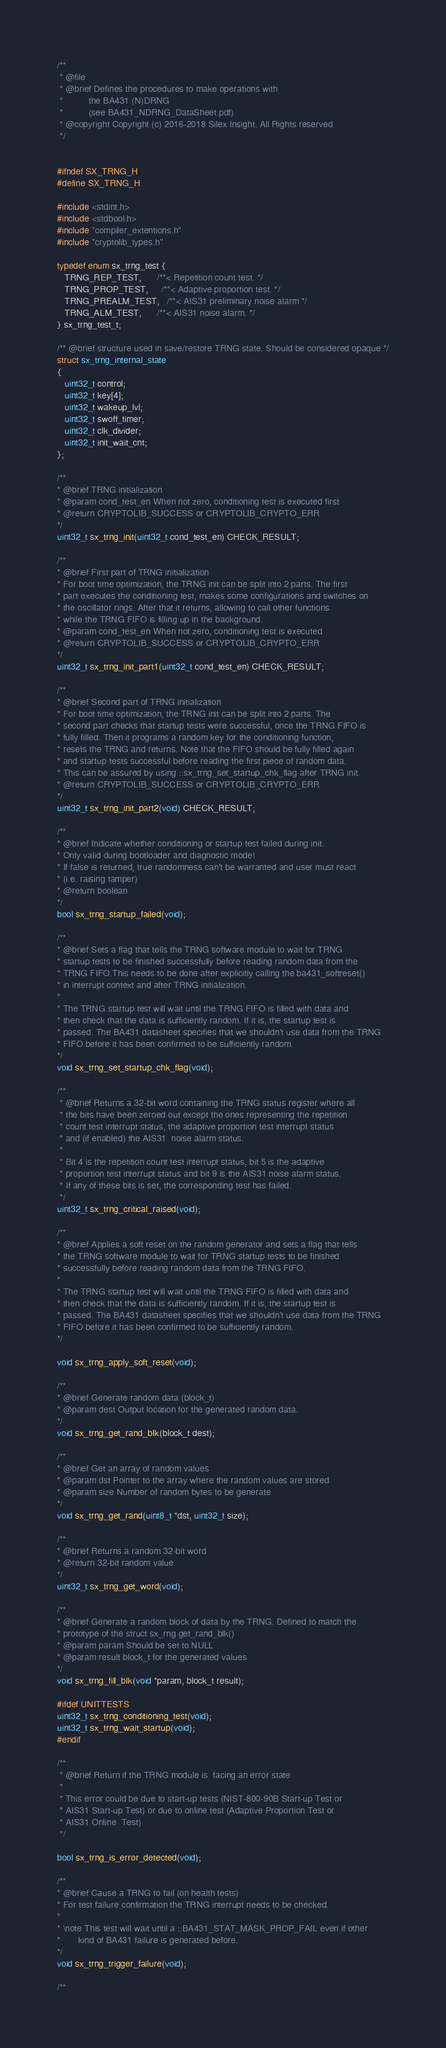Convert code to text. <code><loc_0><loc_0><loc_500><loc_500><_C_>/**
 * @file
 * @brief Defines the procedures to make operations with
 *          the BA431 (N)DRNG
 *          (see BA431_NDRNG_DataSheet.pdf)
 * @copyright Copyright (c) 2016-2018 Silex Insight. All Rights reserved
 */


#ifndef SX_TRNG_H
#define SX_TRNG_H

#include <stdint.h>
#include <stdbool.h>
#include "compiler_extentions.h"
#include "cryptolib_types.h"

typedef enum sx_trng_test {
   TRNG_REP_TEST,      /**< Repetition count test. */
   TRNG_PROP_TEST,     /**< Adaptive proportion test. */
   TRNG_PREALM_TEST,   /**< AIS31 preliminary noise alarm */
   TRNG_ALM_TEST,      /**< AIS31 noise alarm. */
} sx_trng_test_t;

/** @brief structure used in save/restore TRNG state. Should be considered opaque */
struct sx_trng_internal_state
{
   uint32_t control;
   uint32_t key[4];
   uint32_t wakeup_lvl;
   uint32_t swoff_timer;
   uint32_t clk_divider;
   uint32_t init_wait_cnt;
};

/**
* @brief TRNG initialization
* @param cond_test_en When not zero, conditioning test is executed first
* @return CRYPTOLIB_SUCCESS or CRYPTOLIB_CRYPTO_ERR
*/
uint32_t sx_trng_init(uint32_t cond_test_en) CHECK_RESULT;

/**
* @brief First part of TRNG initialization
* For boot time optimization, the TRNG init can be split into 2 parts. The first
* part executes the conditioning test, makes some configurations and switches on
* the oscillator rings. After that it returns, allowing to call other functions
* while the TRNG FIFO is filling up in the background.
* @param cond_test_en When not zero, conditioning test is executed
* @return CRYPTOLIB_SUCCESS or CRYPTOLIB_CRYPTO_ERR
*/
uint32_t sx_trng_init_part1(uint32_t cond_test_en) CHECK_RESULT;

/**
* @brief Second part of TRNG initialization
* For boot time optimization, the TRNG init can be split into 2 parts. The
* second part checks that startup tests were successful, once the TRNG FIFO is
* fully filled. Then it programs a random key for the conditioning function,
* resets the TRNG and returns. Note that the FIFO should be fully filled again
* and startup tests successful before reading the first piece of random data.
* This can be assured by using ::sx_trng_set_startup_chk_flag after TRNG init.
* @return CRYPTOLIB_SUCCESS or CRYPTOLIB_CRYPTO_ERR
*/
uint32_t sx_trng_init_part2(void) CHECK_RESULT;

/**
* @brief Indicate whether conditioning or startup test failed during init.
* Only valid during bootloader and diagnostic mode!
* If false is returned, true randomness can't be warranted and user must react
* (i.e. raising tamper)
* @return boolean
*/
bool sx_trng_startup_failed(void);

/**
* @brief Sets a flag that tells the TRNG software module to wait for TRNG
* startup tests to be finished successfully before reading random data from the
* TRNG FIFO.This needs to be done after explicitly calling the ba431_softreset()
* in interrupt context and after TRNG initialization.
*
* The TRNG startup test will wait until the TRNG FIFO is filled with data and
* then check that the data is sufficiently random. If it is, the startup test is
* passed. The BA431 datasheet specifies that we shouldn't use data from the TRNG
* FIFO before it has been confirmed to be sufficiently random.
*/
void sx_trng_set_startup_chk_flag(void);

/**
 * @brief Returns a 32-bit word containing the TRNG status register where all
 * the bits have been zeroed out except the ones representing the repetition
 * count test interrupt status, the adaptive proportion test interrupt status
 * and (if enabled) the AIS31  noise alarm status.
 *
 * Bit 4 is the repetition count test interrupt status, bit 5 is the adaptive
 * proportion test interrupt status and bit 9 is the AIS31 noise alarm status.
 * If any of these bits is set, the corresponding test has failed.
 */
uint32_t sx_trng_critical_raised(void);

/**
* @brief Applies a soft reset on the random generator and sets a flag that tells
* the TRNG software module to wait for TRNG startup tests to be finished
* successfully before reading random data from the TRNG FIFO.
*
* The TRNG startup test will wait until the TRNG FIFO is filled with data and
* then check that the data is sufficiently random. If it is, the startup test is
* passed. The BA431 datasheet specifies that we shouldn't use data from the TRNG
* FIFO before it has been confirmed to be sufficiently random.
*/

void sx_trng_apply_soft_reset(void);

/**
* @brief Generate random data (block_t)
* @param dest Output location for the generated random data.
*/
void sx_trng_get_rand_blk(block_t dest);

/**
* @brief Get an array of random values
* @param dst Pointer to the array where the random values are stored
* @param size Number of random bytes to be generate
*/
void sx_trng_get_rand(uint8_t *dst, uint32_t size);

/**
* @brief Returns a random 32-bit word
* @return 32-bit random value
*/
uint32_t sx_trng_get_word(void);

/**
* @brief Generate a random block of data by the TRNG. Defined to match the
* prototype of the struct sx_rng get_rand_blk()
* @param param Should be set to NULL
* @param result block_t for the generated values
*/
void sx_trng_fill_blk(void *param, block_t result);

#ifdef UNITTESTS
uint32_t sx_trng_conditioning_test(void);
uint32_t sx_trng_wait_startup(void);
#endif

/**
 * @brief Return if the TRNG module is  facing an error state
 *
 * This error could be due to start-up tests (NIST-800-90B Start-up Test or
 * AIS31 Start-up Test) or due to online test (Adaptive Proportion Test or
 * AIS31 Online  Test)
 */

bool sx_trng_is_error_detected(void);

/**
* @brief Cause a TRNG to fail (on health tests)
* For test failure confirmation the TRNG interrupt needs to be checked.
*
* \note This test will wait until a ::BA431_STAT_MASK_PROP_FAIL even if other
*       kind of BA431 failure is generated before.
*/
void sx_trng_trigger_failure(void);

/**</code> 